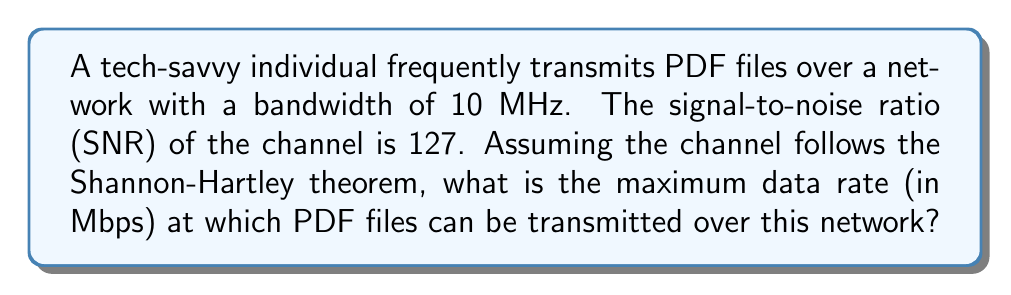Can you solve this math problem? To solve this problem, we'll use the Shannon-Hartley theorem, which gives us the channel capacity for a noisy communication channel. The theorem is expressed as:

$$C = B \log_2(1 + SNR)$$

Where:
$C$ = Channel capacity (bits per second)
$B$ = Bandwidth (Hz)
$SNR$ = Signal-to-noise ratio (linear scale, not dB)

Given:
- Bandwidth $(B) = 10$ MHz $= 10 \times 10^6$ Hz
- SNR $= 127$

Let's calculate the channel capacity:

$$\begin{align}
C &= (10 \times 10^6) \log_2(1 + 127) \\
&= (10 \times 10^6) \log_2(128) \\
&= (10 \times 10^6) \times 7 \\
&= 70 \times 10^6 \text{ bits per second}
\end{align}$$

To convert this to Mbps (Megabits per second), we divide by $10^6$:

$$70 \times 10^6 \text{ bps} = 70 \text{ Mbps}$$

This represents the theoretical maximum data rate at which PDF files can be transmitted over the given network, assuming ideal encoding and error-correction techniques are used.
Answer: 70 Mbps 